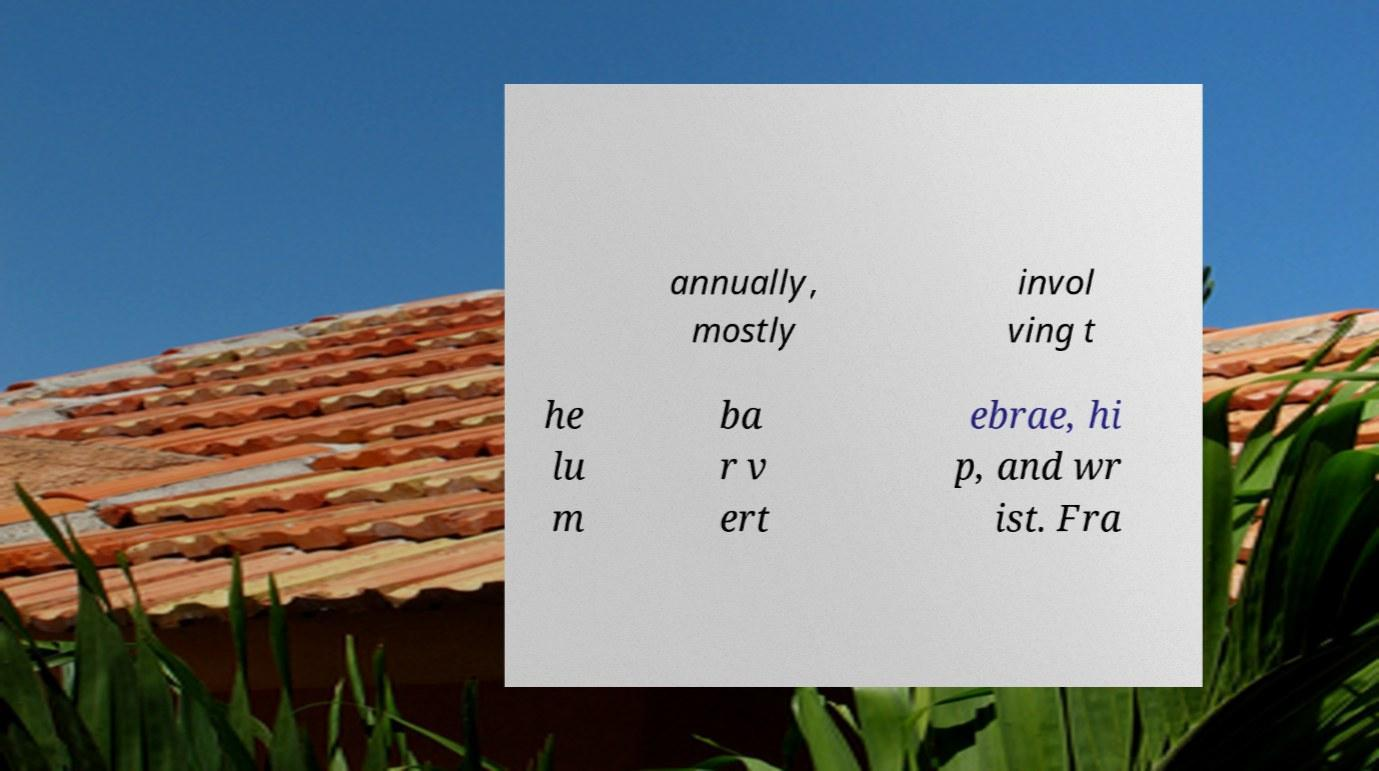I need the written content from this picture converted into text. Can you do that? annually, mostly invol ving t he lu m ba r v ert ebrae, hi p, and wr ist. Fra 